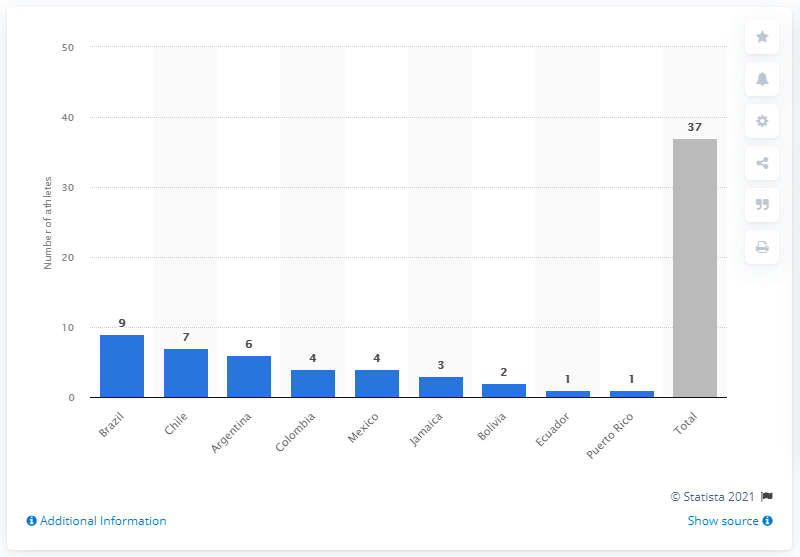Indicate a few pertinent items in this graphic. In addition to Brazil, another country that had seven athletes from the PyeongChang Winter Games was Chile. 